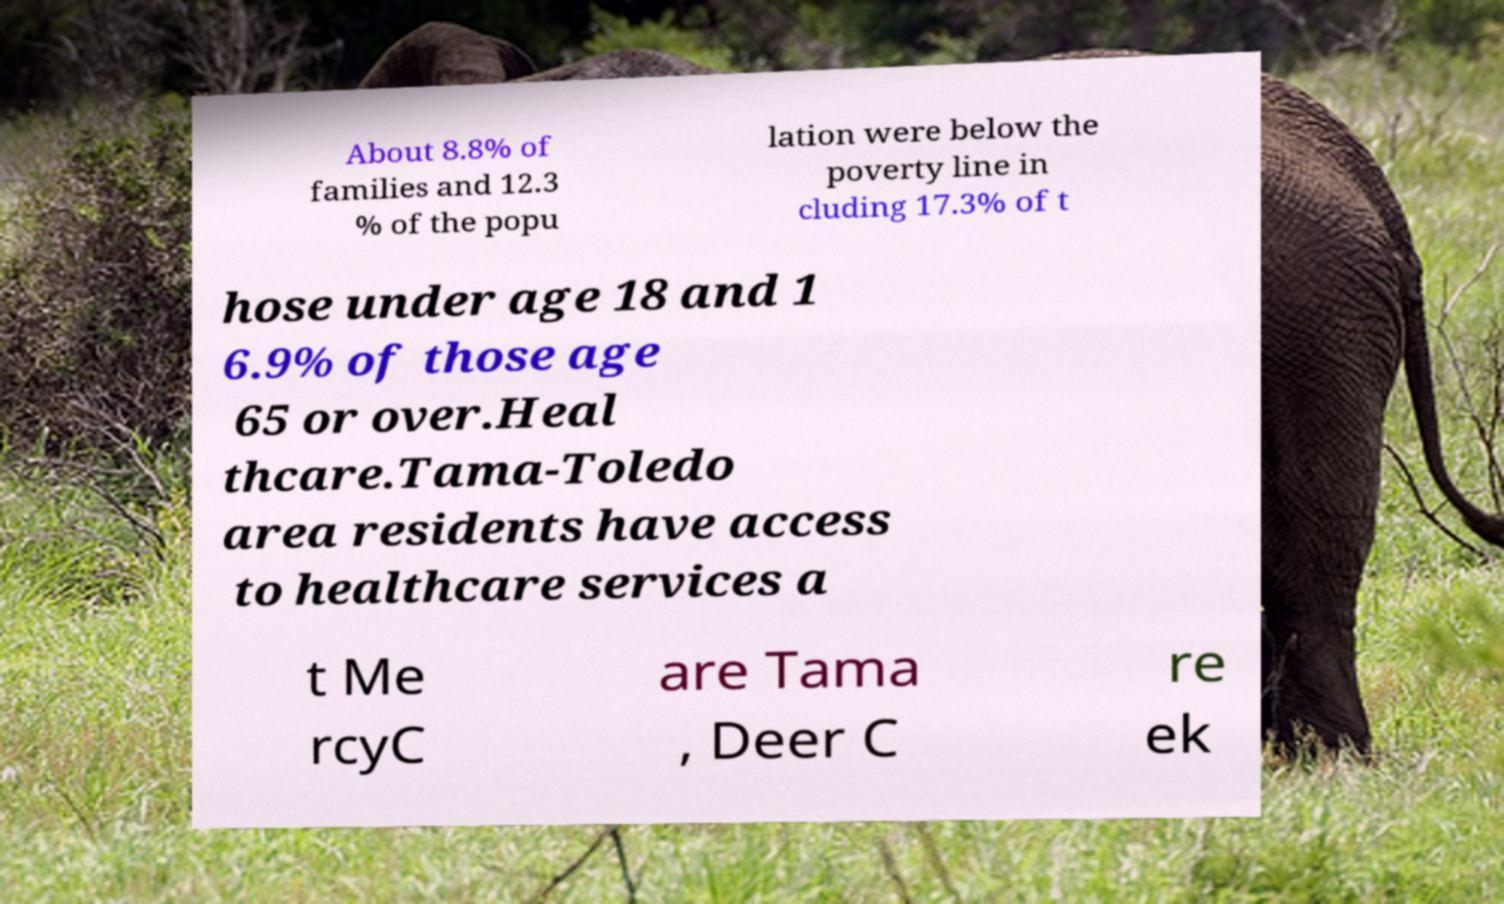What messages or text are displayed in this image? I need them in a readable, typed format. About 8.8% of families and 12.3 % of the popu lation were below the poverty line in cluding 17.3% of t hose under age 18 and 1 6.9% of those age 65 or over.Heal thcare.Tama-Toledo area residents have access to healthcare services a t Me rcyC are Tama , Deer C re ek 